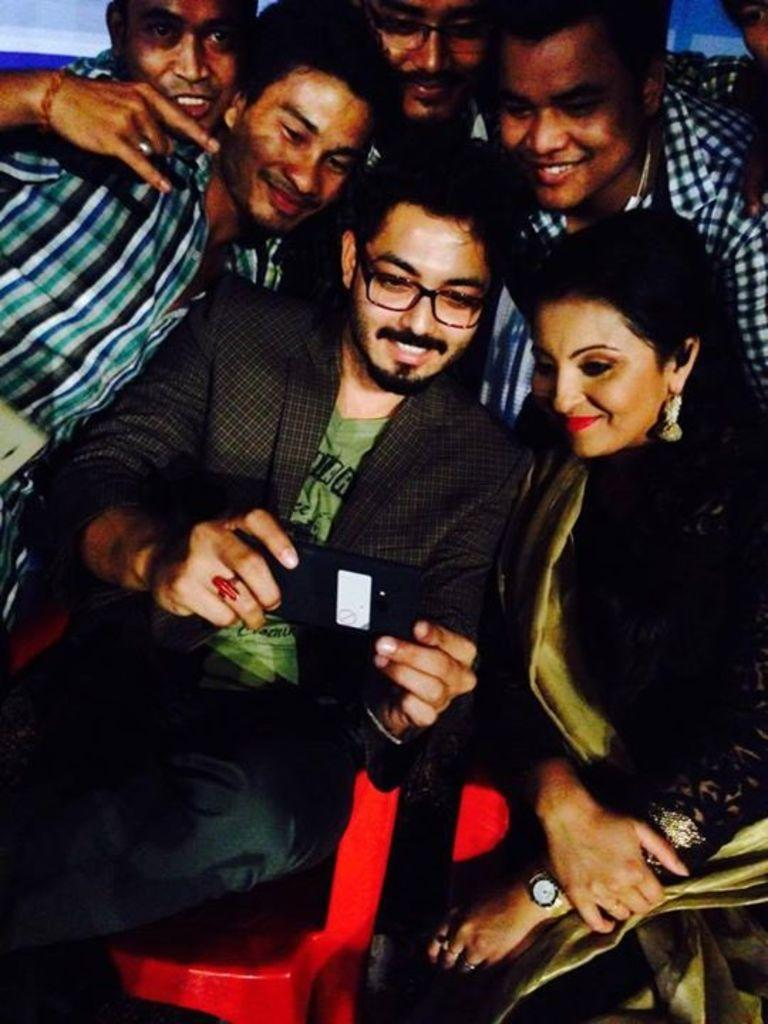How many people are in the image? There is a group of people in the image. What is one person in the group doing? One person is holding an object. Can you describe anything in the background of the image? There are objects visible in the background of the image. What type of fiction is the person holding in the image? There is no indication in the image that the person is holding any type of fiction, as the object they are holding is not described in the provided facts. 